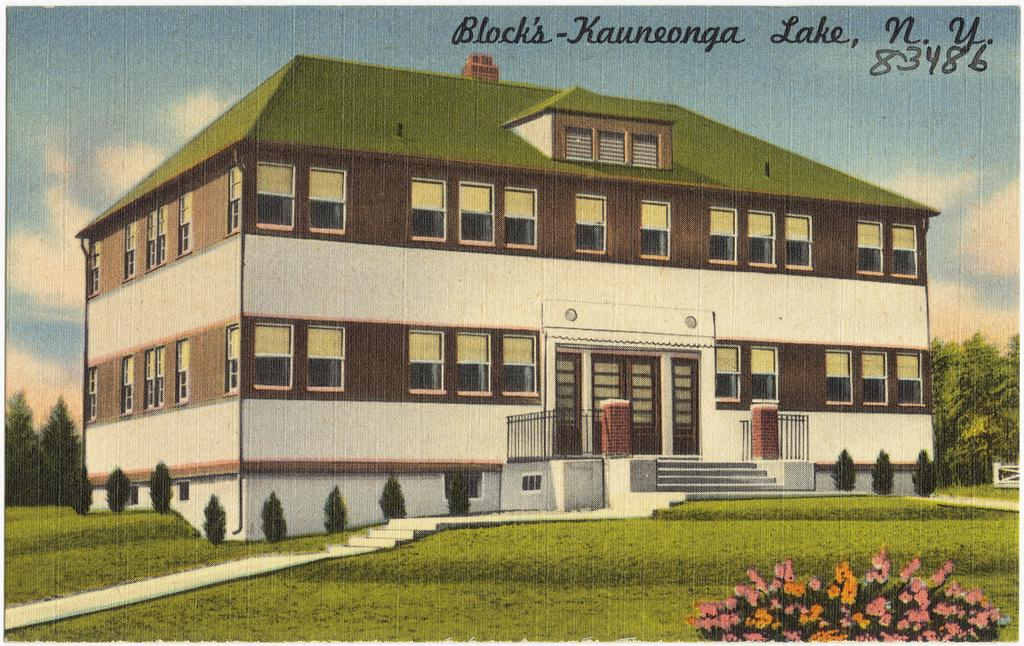What type of terrain is visible in the foreground of the image? There is grassland in the foreground of the image. What architectural feature can be seen in the foreground of the image? There are stairs in the foreground of the image. What type of vegetation is present in the foreground of the image? There are trees and flowers in the foreground of the image. What structure is visible in the image? There is a building in the image. What is visible in the sky in the image? The sky is visible in the image, and there are clouds in the sky. What is written at the top of the image? There is some text at the top of the image. What type of wire is holding the flowers in the image? There is no wire holding the flowers in the image; they are growing naturally in the grassland. What type of brass object can be seen near the building in the image? There is no brass object visible near the building in the image. 